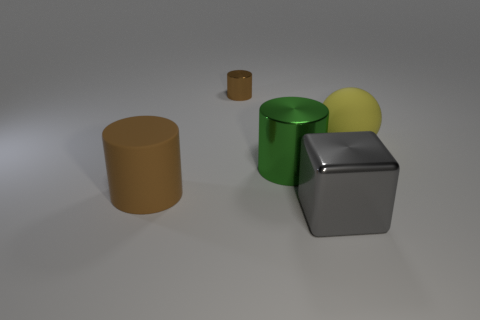There is a big object in front of the brown thing that is in front of the small brown object; what is its color?
Your response must be concise. Gray. There is a brown cylinder behind the brown object that is in front of the large rubber object that is to the right of the large block; how big is it?
Your answer should be very brief. Small. Are there fewer big cylinders that are on the right side of the green metallic cylinder than rubber objects in front of the matte sphere?
Provide a short and direct response. Yes. What number of other balls have the same material as the large ball?
Make the answer very short. 0. Are there any gray metallic cubes that are in front of the thing that is to the right of the big shiny object in front of the big green metal cylinder?
Provide a succinct answer. Yes. There is a small brown thing that is the same material as the large gray object; what shape is it?
Offer a terse response. Cylinder. Is the number of blocks greater than the number of large blue shiny cylinders?
Your answer should be compact. Yes. Do the large brown rubber object and the brown object behind the large sphere have the same shape?
Give a very brief answer. Yes. What is the large brown cylinder made of?
Provide a succinct answer. Rubber. What is the color of the shiny cylinder that is behind the big cylinder that is right of the thing that is behind the yellow rubber sphere?
Your answer should be very brief. Brown. 